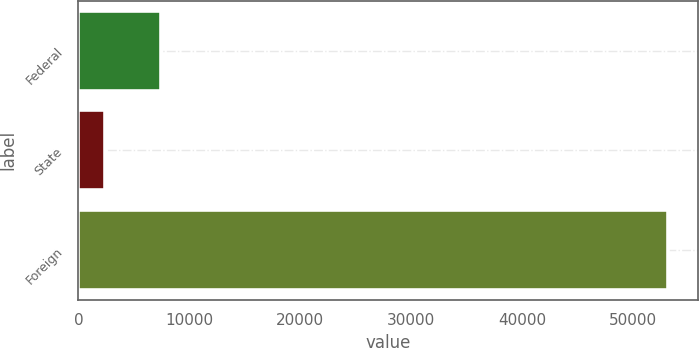<chart> <loc_0><loc_0><loc_500><loc_500><bar_chart><fcel>Federal<fcel>State<fcel>Foreign<nl><fcel>7454.4<fcel>2377<fcel>53151<nl></chart> 